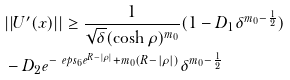<formula> <loc_0><loc_0><loc_500><loc_500>& | | U ^ { \prime } ( x ) | | \geq \frac { 1 } { \sqrt { \delta } ( \cosh \rho ) ^ { m _ { 0 } } } ( 1 - D _ { 1 } \delta ^ { m _ { 0 } - \frac { 1 } { 2 } } ) \\ & - D _ { 2 } e ^ { - \ e p s _ { 6 } e ^ { R - | \rho | } + m _ { 0 } ( R - | \rho | ) } \delta ^ { m _ { 0 } - \frac { 1 } { 2 } }</formula> 